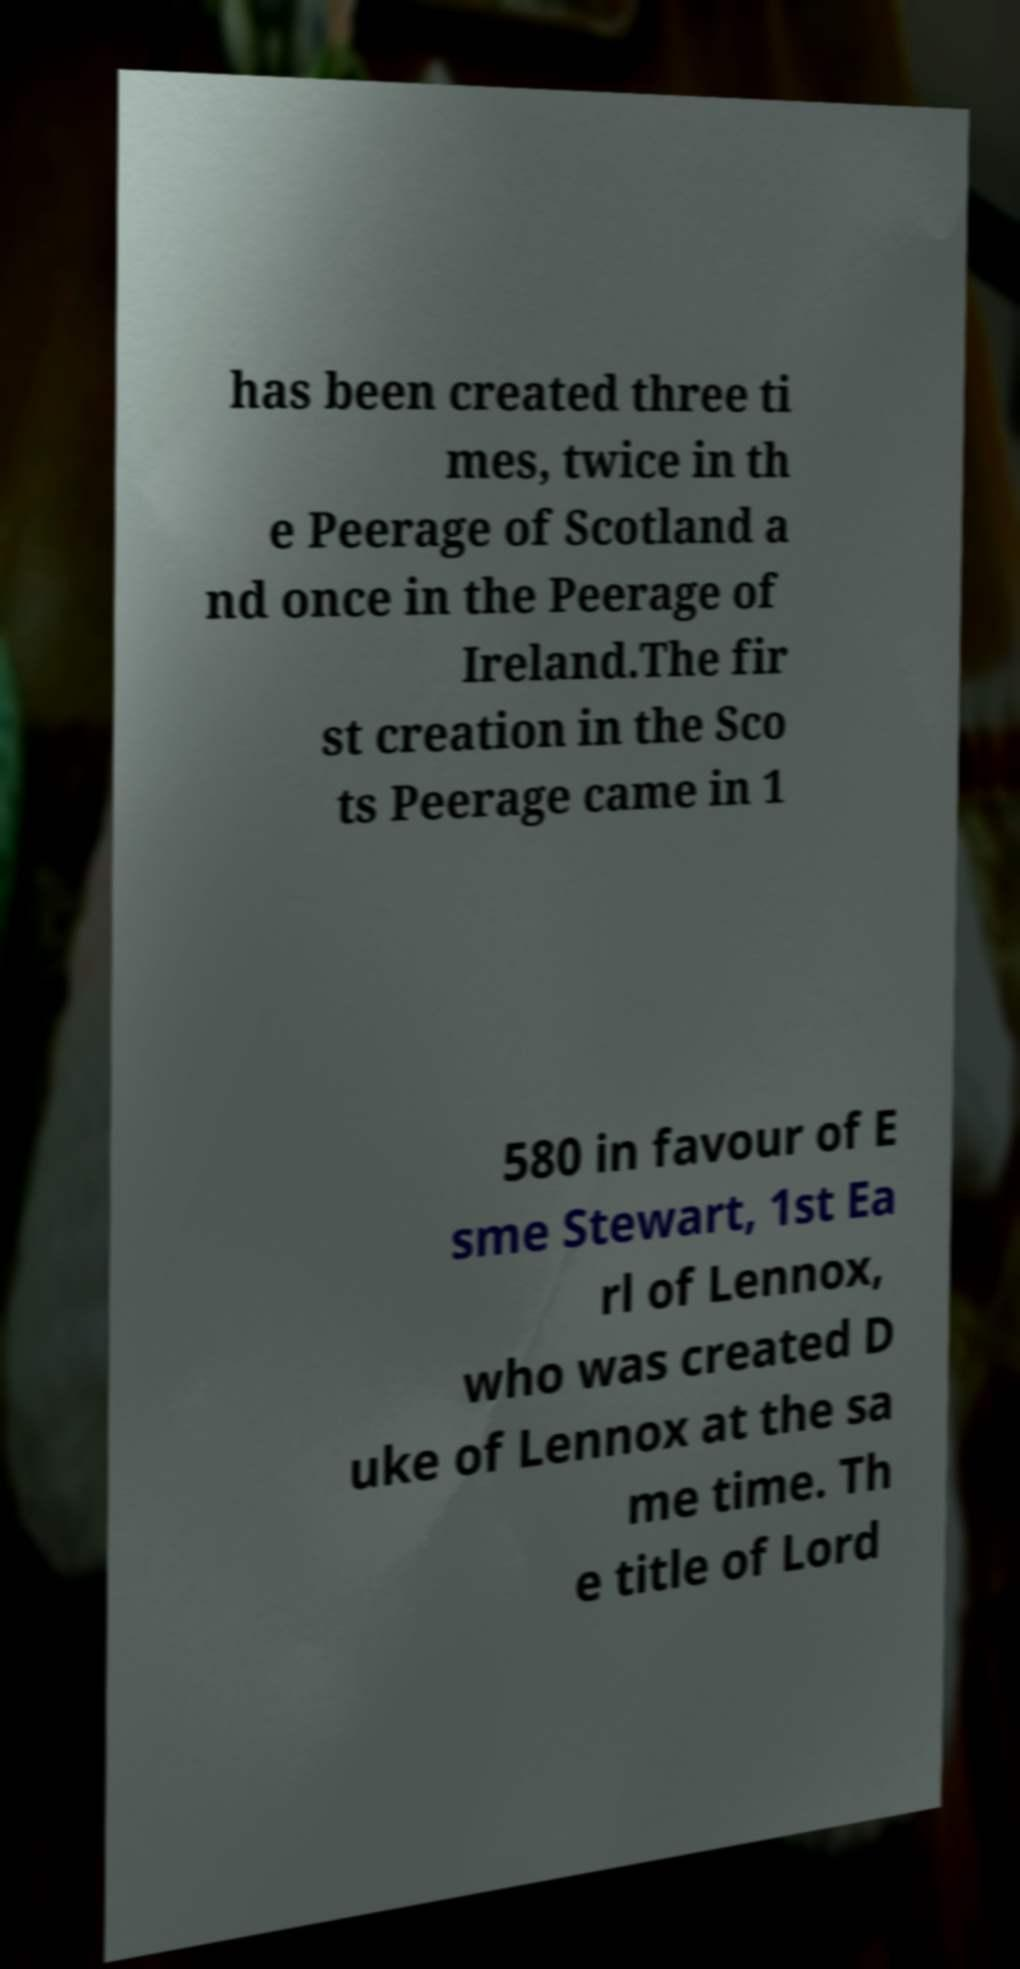I need the written content from this picture converted into text. Can you do that? has been created three ti mes, twice in th e Peerage of Scotland a nd once in the Peerage of Ireland.The fir st creation in the Sco ts Peerage came in 1 580 in favour of E sme Stewart, 1st Ea rl of Lennox, who was created D uke of Lennox at the sa me time. Th e title of Lord 